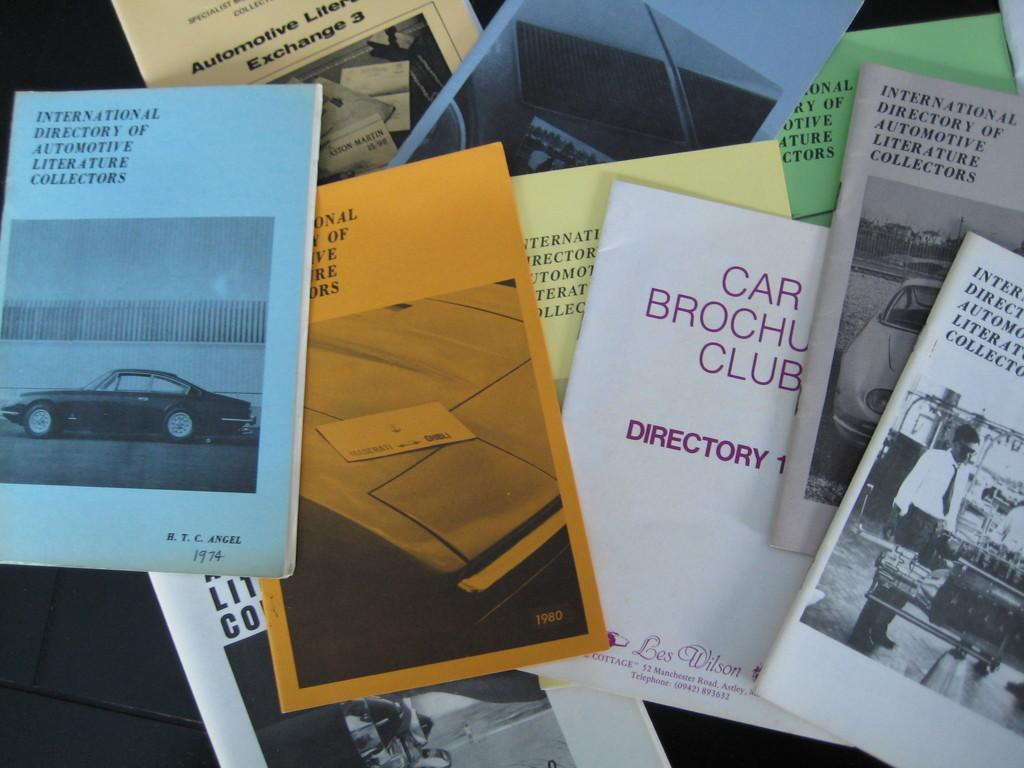<image>
Share a concise interpretation of the image provided. books piled on one another with one of them titled 'international directory of automotive literature collectors' 